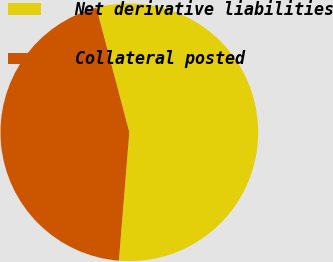<chart> <loc_0><loc_0><loc_500><loc_500><pie_chart><fcel>Net derivative liabilities<fcel>Collateral posted<nl><fcel>55.4%<fcel>44.6%<nl></chart> 